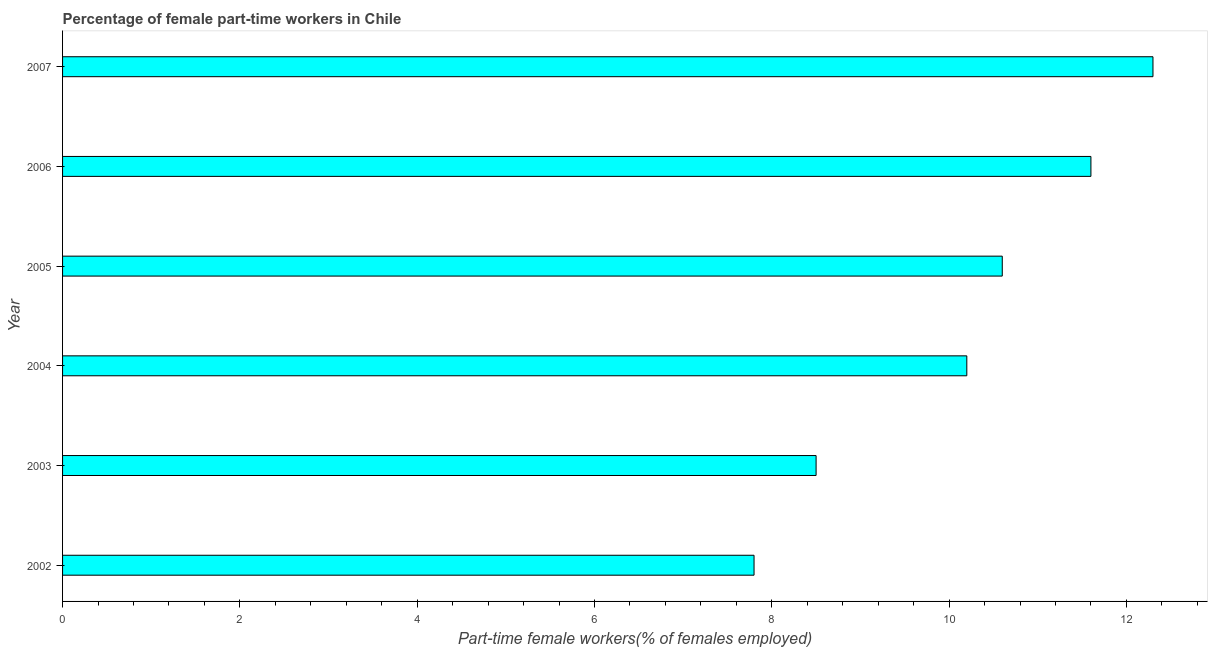Does the graph contain grids?
Offer a very short reply. No. What is the title of the graph?
Offer a very short reply. Percentage of female part-time workers in Chile. What is the label or title of the X-axis?
Provide a succinct answer. Part-time female workers(% of females employed). What is the percentage of part-time female workers in 2004?
Your answer should be very brief. 10.2. Across all years, what is the maximum percentage of part-time female workers?
Offer a terse response. 12.3. Across all years, what is the minimum percentage of part-time female workers?
Your response must be concise. 7.8. What is the sum of the percentage of part-time female workers?
Provide a succinct answer. 61. What is the difference between the percentage of part-time female workers in 2002 and 2007?
Provide a short and direct response. -4.5. What is the average percentage of part-time female workers per year?
Keep it short and to the point. 10.17. What is the median percentage of part-time female workers?
Offer a terse response. 10.4. What is the ratio of the percentage of part-time female workers in 2002 to that in 2004?
Your response must be concise. 0.77. What is the difference between the highest and the second highest percentage of part-time female workers?
Offer a very short reply. 0.7. Is the sum of the percentage of part-time female workers in 2002 and 2007 greater than the maximum percentage of part-time female workers across all years?
Your answer should be very brief. Yes. In how many years, is the percentage of part-time female workers greater than the average percentage of part-time female workers taken over all years?
Provide a succinct answer. 4. How many bars are there?
Keep it short and to the point. 6. Are all the bars in the graph horizontal?
Keep it short and to the point. Yes. How many years are there in the graph?
Your answer should be very brief. 6. What is the difference between two consecutive major ticks on the X-axis?
Keep it short and to the point. 2. What is the Part-time female workers(% of females employed) in 2002?
Offer a very short reply. 7.8. What is the Part-time female workers(% of females employed) of 2003?
Ensure brevity in your answer.  8.5. What is the Part-time female workers(% of females employed) in 2004?
Keep it short and to the point. 10.2. What is the Part-time female workers(% of females employed) in 2005?
Provide a succinct answer. 10.6. What is the Part-time female workers(% of females employed) of 2006?
Your response must be concise. 11.6. What is the Part-time female workers(% of females employed) in 2007?
Provide a short and direct response. 12.3. What is the difference between the Part-time female workers(% of females employed) in 2002 and 2004?
Provide a succinct answer. -2.4. What is the difference between the Part-time female workers(% of females employed) in 2002 and 2007?
Offer a very short reply. -4.5. What is the difference between the Part-time female workers(% of females employed) in 2003 and 2004?
Your answer should be very brief. -1.7. What is the difference between the Part-time female workers(% of females employed) in 2003 and 2005?
Provide a succinct answer. -2.1. What is the difference between the Part-time female workers(% of females employed) in 2003 and 2007?
Give a very brief answer. -3.8. What is the difference between the Part-time female workers(% of females employed) in 2004 and 2005?
Offer a terse response. -0.4. What is the difference between the Part-time female workers(% of females employed) in 2004 and 2007?
Your answer should be very brief. -2.1. What is the difference between the Part-time female workers(% of females employed) in 2005 and 2007?
Your answer should be compact. -1.7. What is the difference between the Part-time female workers(% of females employed) in 2006 and 2007?
Ensure brevity in your answer.  -0.7. What is the ratio of the Part-time female workers(% of females employed) in 2002 to that in 2003?
Make the answer very short. 0.92. What is the ratio of the Part-time female workers(% of females employed) in 2002 to that in 2004?
Provide a short and direct response. 0.77. What is the ratio of the Part-time female workers(% of females employed) in 2002 to that in 2005?
Your response must be concise. 0.74. What is the ratio of the Part-time female workers(% of females employed) in 2002 to that in 2006?
Offer a very short reply. 0.67. What is the ratio of the Part-time female workers(% of females employed) in 2002 to that in 2007?
Give a very brief answer. 0.63. What is the ratio of the Part-time female workers(% of females employed) in 2003 to that in 2004?
Keep it short and to the point. 0.83. What is the ratio of the Part-time female workers(% of females employed) in 2003 to that in 2005?
Provide a short and direct response. 0.8. What is the ratio of the Part-time female workers(% of females employed) in 2003 to that in 2006?
Your response must be concise. 0.73. What is the ratio of the Part-time female workers(% of females employed) in 2003 to that in 2007?
Your answer should be compact. 0.69. What is the ratio of the Part-time female workers(% of females employed) in 2004 to that in 2005?
Offer a terse response. 0.96. What is the ratio of the Part-time female workers(% of females employed) in 2004 to that in 2006?
Your answer should be very brief. 0.88. What is the ratio of the Part-time female workers(% of females employed) in 2004 to that in 2007?
Provide a short and direct response. 0.83. What is the ratio of the Part-time female workers(% of females employed) in 2005 to that in 2006?
Your response must be concise. 0.91. What is the ratio of the Part-time female workers(% of females employed) in 2005 to that in 2007?
Your answer should be compact. 0.86. What is the ratio of the Part-time female workers(% of females employed) in 2006 to that in 2007?
Provide a short and direct response. 0.94. 